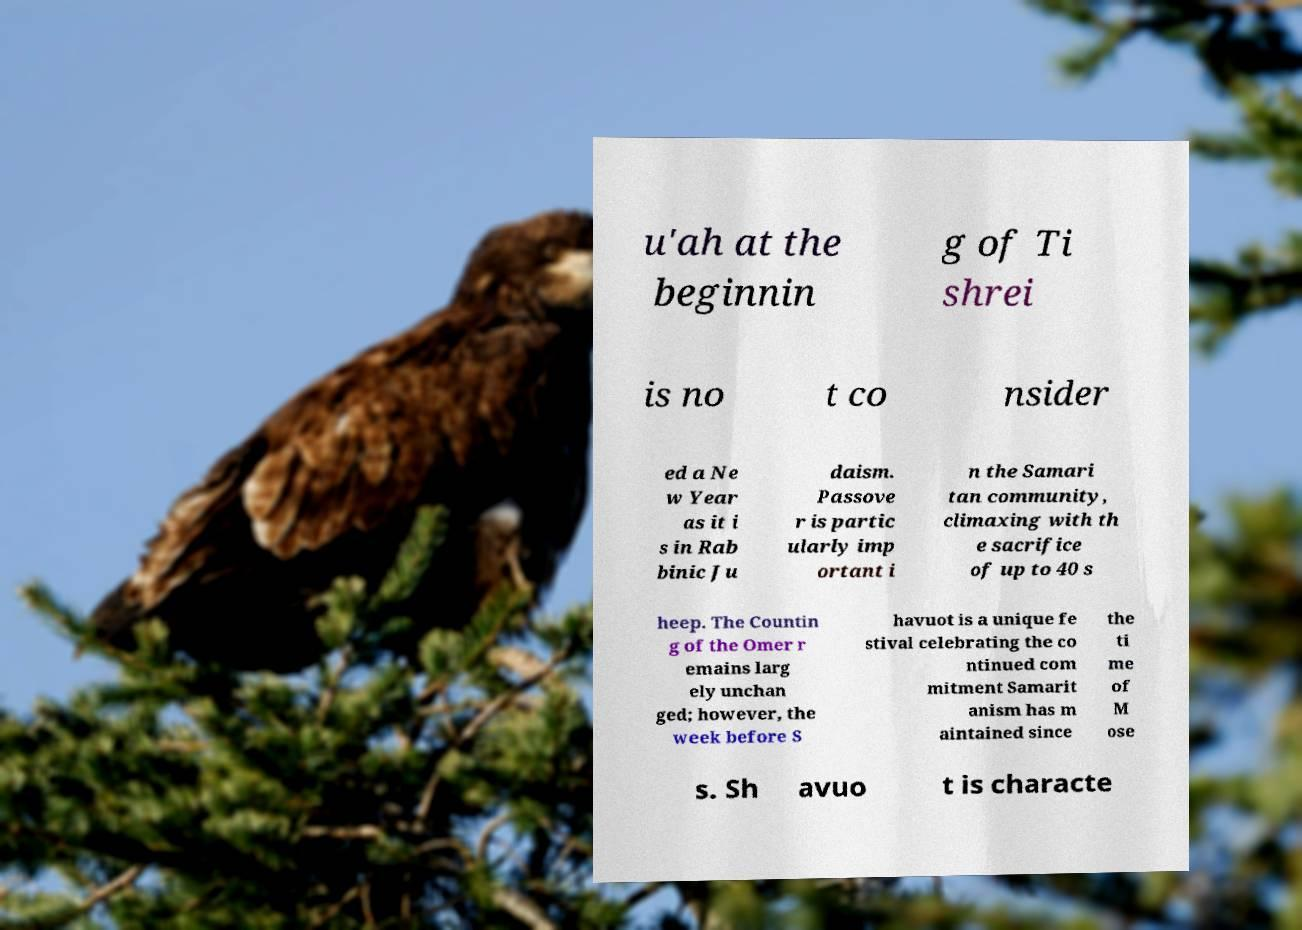What messages or text are displayed in this image? I need them in a readable, typed format. u'ah at the beginnin g of Ti shrei is no t co nsider ed a Ne w Year as it i s in Rab binic Ju daism. Passove r is partic ularly imp ortant i n the Samari tan community, climaxing with th e sacrifice of up to 40 s heep. The Countin g of the Omer r emains larg ely unchan ged; however, the week before S havuot is a unique fe stival celebrating the co ntinued com mitment Samarit anism has m aintained since the ti me of M ose s. Sh avuo t is characte 